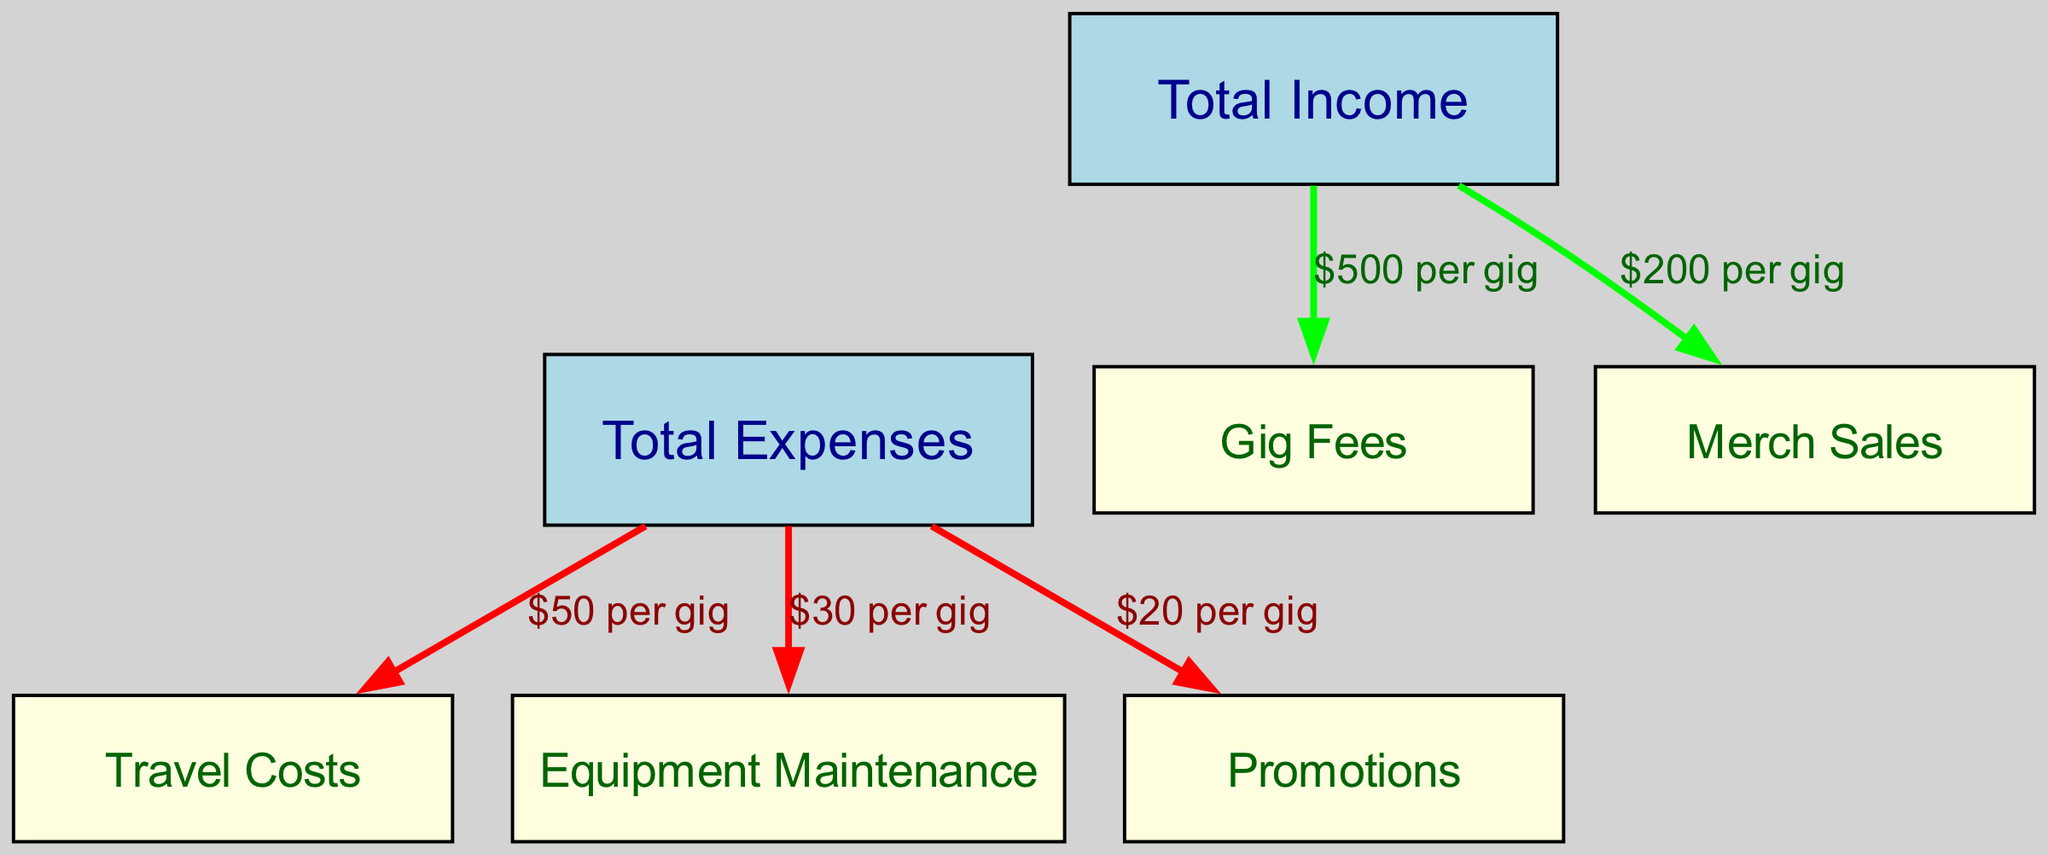What is the total income from gig fees? The diagram indicates that gig fees contribute $500 per gig to total income.
Answer: $500 What are the total expenses from travel costs? The diagram shows that travel costs are $50 per gig as an expense.
Answer: $50 How many nodes are present in the diagram? The diagram includes a total of 7 nodes, representing income, expenses, gig fees, merch sales, travel costs, equipment maintenance, and promotions.
Answer: 7 What is the contribution of merch sales to total income? According to the diagram, merch sales add $200 per gig to total income.
Answer: $200 Which node is directly connected to both income and expenses? The "gigFees" node is directly connected to "income," and "travelCosts," "equipmentMaintenance," and "promotions" nodes are connected to "expenses."
Answer: gigFees What is the combined total of equipment maintenance and promotions expenses? The diagram indicates that equipment maintenance costs $30 per gig and promotions cost $20 per gig. Therefore, the total combined is 30 + 20 = 50.
Answer: $50 If a DJ performs two gigs, what would be the total income? Each gig generates $500 from fees and $200 from merch sales, leading to a total of (500 + 200) * 2 = $1400 for two gigs.
Answer: $1400 What is the total income from all revenue streams? Total income includes gig fees of $500 and merch sales of $200, summing up to $700 per gig.
Answer: $700 